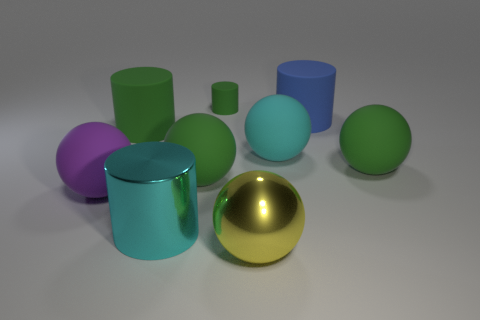Subtract all yellow cylinders. How many green balls are left? 2 Subtract all cyan spheres. How many spheres are left? 4 Subtract all large green matte cylinders. How many cylinders are left? 3 Subtract all brown spheres. Subtract all blue cylinders. How many spheres are left? 5 Subtract all cylinders. How many objects are left? 5 Add 5 big yellow balls. How many big yellow balls exist? 6 Subtract 0 gray cylinders. How many objects are left? 9 Subtract all yellow metallic cylinders. Subtract all yellow shiny balls. How many objects are left? 8 Add 6 big blue objects. How many big blue objects are left? 7 